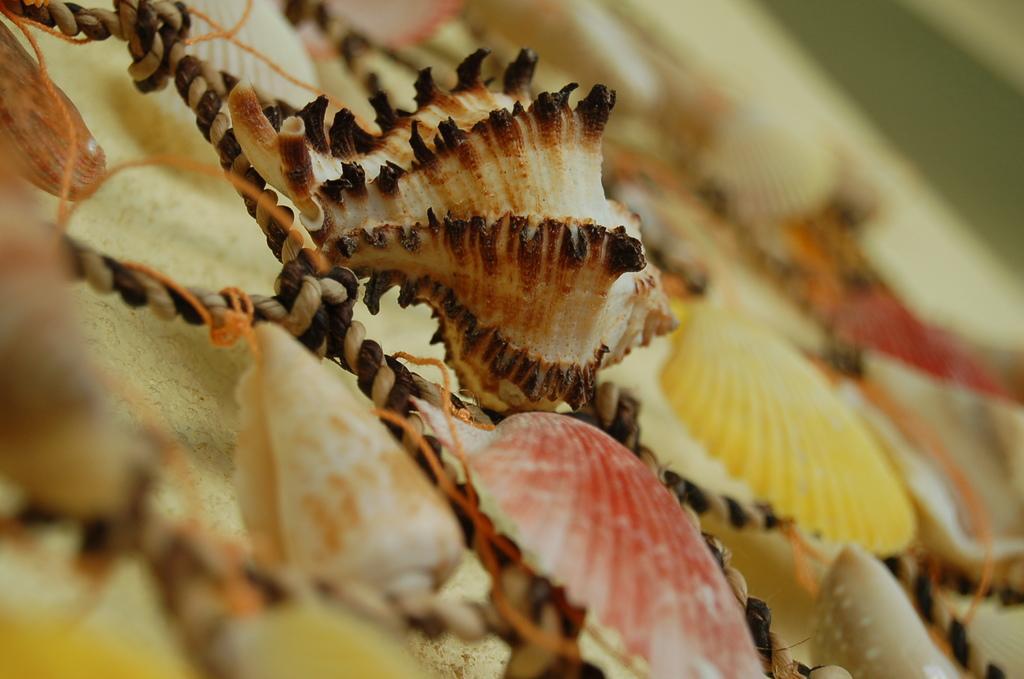Describe this image in one or two sentences. In this picture I can see few seashells to the ropes. 